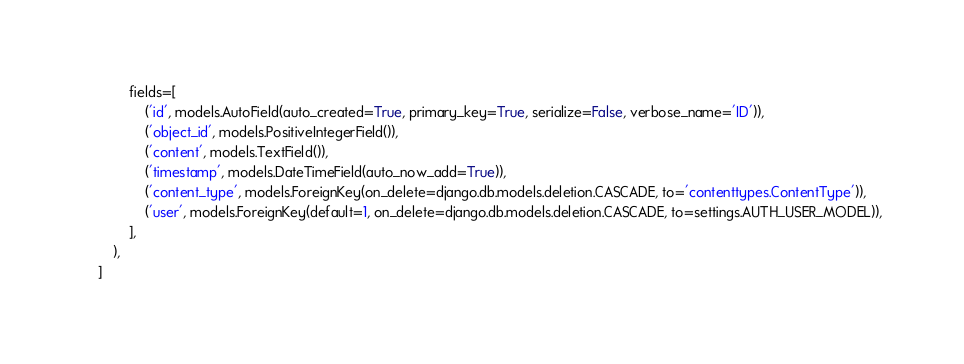Convert code to text. <code><loc_0><loc_0><loc_500><loc_500><_Python_>            fields=[
                ('id', models.AutoField(auto_created=True, primary_key=True, serialize=False, verbose_name='ID')),
                ('object_id', models.PositiveIntegerField()),
                ('content', models.TextField()),
                ('timestamp', models.DateTimeField(auto_now_add=True)),
                ('content_type', models.ForeignKey(on_delete=django.db.models.deletion.CASCADE, to='contenttypes.ContentType')),
                ('user', models.ForeignKey(default=1, on_delete=django.db.models.deletion.CASCADE, to=settings.AUTH_USER_MODEL)),
            ],
        ),
    ]
</code> 